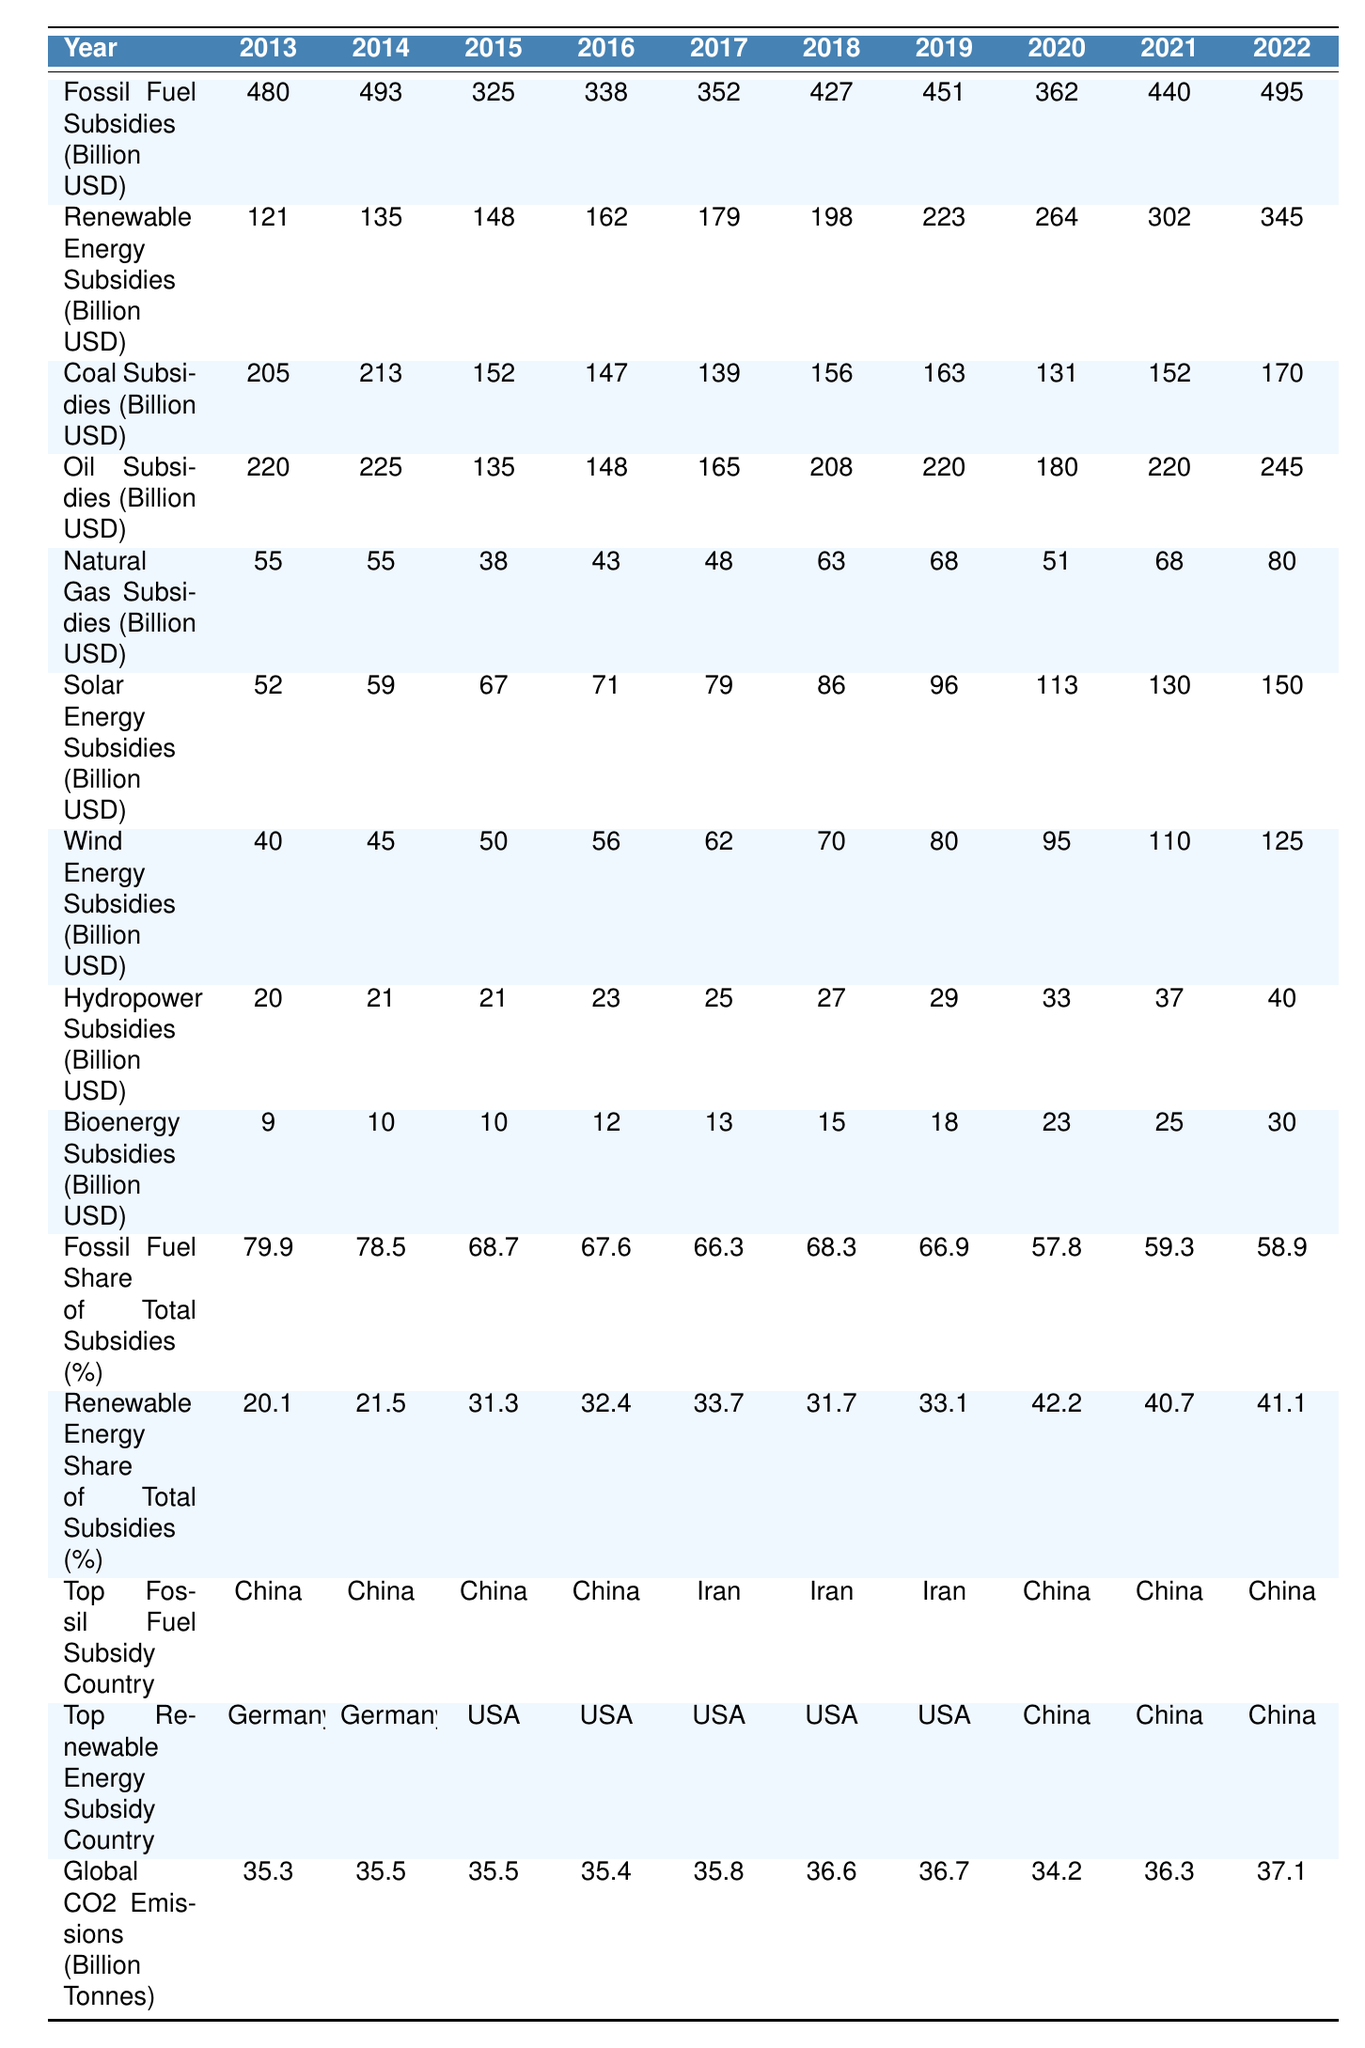What was the highest amount of renewable energy subsidies in a single year? The highest amount of renewable energy subsidies occurred in 2022, which is 345 billion USD.
Answer: 345 billion USD In which year did fossil fuel subsidies peak? Fossil fuel subsidies peaked in 2022 at 495 billion USD.
Answer: 495 billion USD What is the average fossil fuel subsidy over the past decade? The average is calculated as (480 + 493 + 325 + 338 + 352 + 427 + 451 + 362 + 440 + 495) / 10 = 427.3 billion USD.
Answer: 427.3 billion USD How much did renewable energy subsidies increase from 2013 to 2022? The increase is calculated as 345 billion USD (2022) - 121 billion USD (2013) = 224 billion USD.
Answer: 224 billion USD What was the share of renewable energy subsidies in 2015? The share of renewable energy subsidies in 2015 was 31.3%.
Answer: 31.3% Which fossil fuel received the highest subsidies in 2020? In 2020, oil subsidies were the highest, totaling 180 billion USD.
Answer: 180 billion USD What was the total fossil fuel subsidy for the years 2019 and 2020 combined? The total for 2019 and 2020 is 451 billion USD (2019) + 362 billion USD (2020) = 813 billion USD.
Answer: 813 billion USD Did the share of renewable energy subsidies surpass fossil fuel subsidies in any year? Yes, in 2020 the share of renewable energy subsidies was 42.2%, while fossil fuel subsidies were at 57.8%.
Answer: Yes What is the difference between the fossil fuel and renewable energy subsidies in 2018? The difference is calculated as 427 billion USD (fossil fuel) - 198 billion USD (renewable) = 229 billion USD.
Answer: 229 billion USD Which country was the top renewable energy subsidy country for most years in the past decade? The USA was the top renewable energy subsidy country from 2015 to 2019, then China from 2020 to 2022.
Answer: USA 